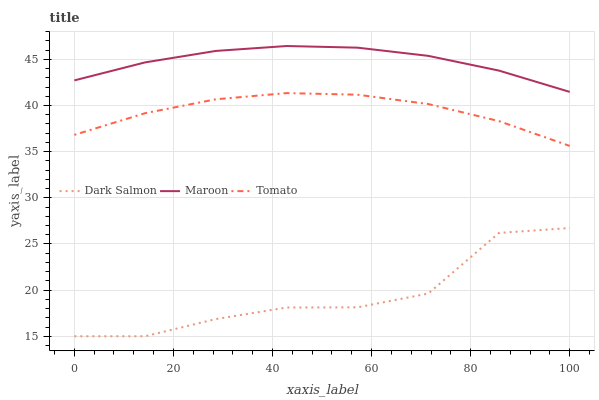Does Dark Salmon have the minimum area under the curve?
Answer yes or no. Yes. Does Maroon have the maximum area under the curve?
Answer yes or no. Yes. Does Maroon have the minimum area under the curve?
Answer yes or no. No. Does Dark Salmon have the maximum area under the curve?
Answer yes or no. No. Is Maroon the smoothest?
Answer yes or no. Yes. Is Dark Salmon the roughest?
Answer yes or no. Yes. Is Dark Salmon the smoothest?
Answer yes or no. No. Is Maroon the roughest?
Answer yes or no. No. Does Dark Salmon have the lowest value?
Answer yes or no. Yes. Does Maroon have the lowest value?
Answer yes or no. No. Does Maroon have the highest value?
Answer yes or no. Yes. Does Dark Salmon have the highest value?
Answer yes or no. No. Is Dark Salmon less than Tomato?
Answer yes or no. Yes. Is Tomato greater than Dark Salmon?
Answer yes or no. Yes. Does Dark Salmon intersect Tomato?
Answer yes or no. No. 